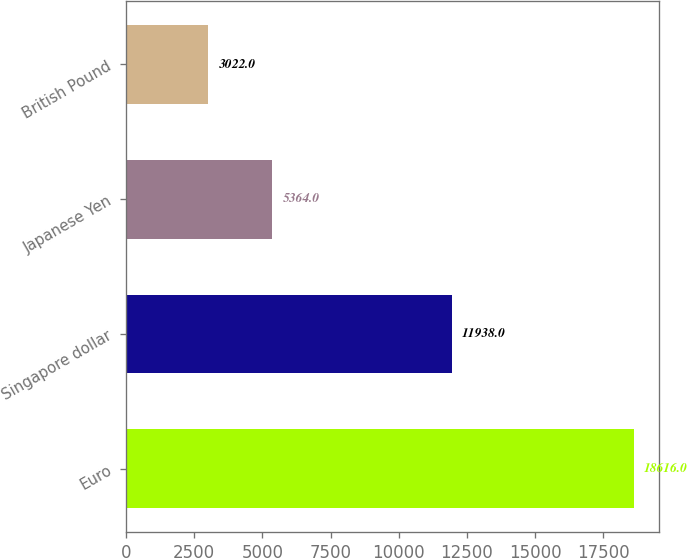Convert chart. <chart><loc_0><loc_0><loc_500><loc_500><bar_chart><fcel>Euro<fcel>Singapore dollar<fcel>Japanese Yen<fcel>British Pound<nl><fcel>18616<fcel>11938<fcel>5364<fcel>3022<nl></chart> 